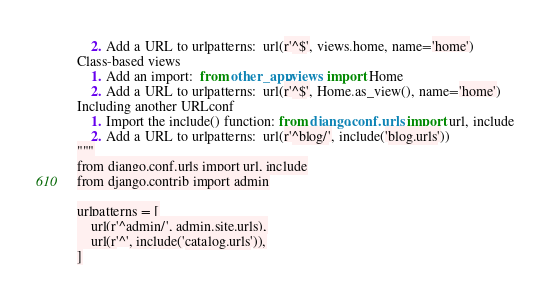Convert code to text. <code><loc_0><loc_0><loc_500><loc_500><_Python_>    2. Add a URL to urlpatterns:  url(r'^$', views.home, name='home')
Class-based views
    1. Add an import:  from other_app.views import Home
    2. Add a URL to urlpatterns:  url(r'^$', Home.as_view(), name='home')
Including another URLconf
    1. Import the include() function: from django.conf.urls import url, include
    2. Add a URL to urlpatterns:  url(r'^blog/', include('blog.urls'))
"""
from django.conf.urls import url, include
from django.contrib import admin

urlpatterns = [
    url(r'^admin/', admin.site.urls),
    url(r'^', include('catalog.urls')),
]
</code> 